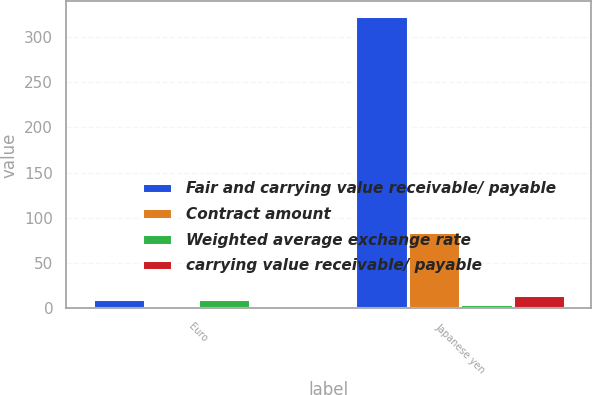Convert chart to OTSL. <chart><loc_0><loc_0><loc_500><loc_500><stacked_bar_chart><ecel><fcel>Euro<fcel>Japanese yen<nl><fcel>Fair and carrying value receivable/ payable<fcel>10<fcel>323<nl><fcel>Contract amount<fcel>1.31<fcel>84.4<nl><fcel>Weighted average exchange rate<fcel>10<fcel>5<nl><fcel>carrying value receivable/ payable<fcel>2<fcel>15<nl></chart> 